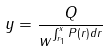<formula> <loc_0><loc_0><loc_500><loc_500>y = \frac { Q } { w ^ { \int _ { r _ { 1 } } ^ { x } P ( r ) d r } }</formula> 